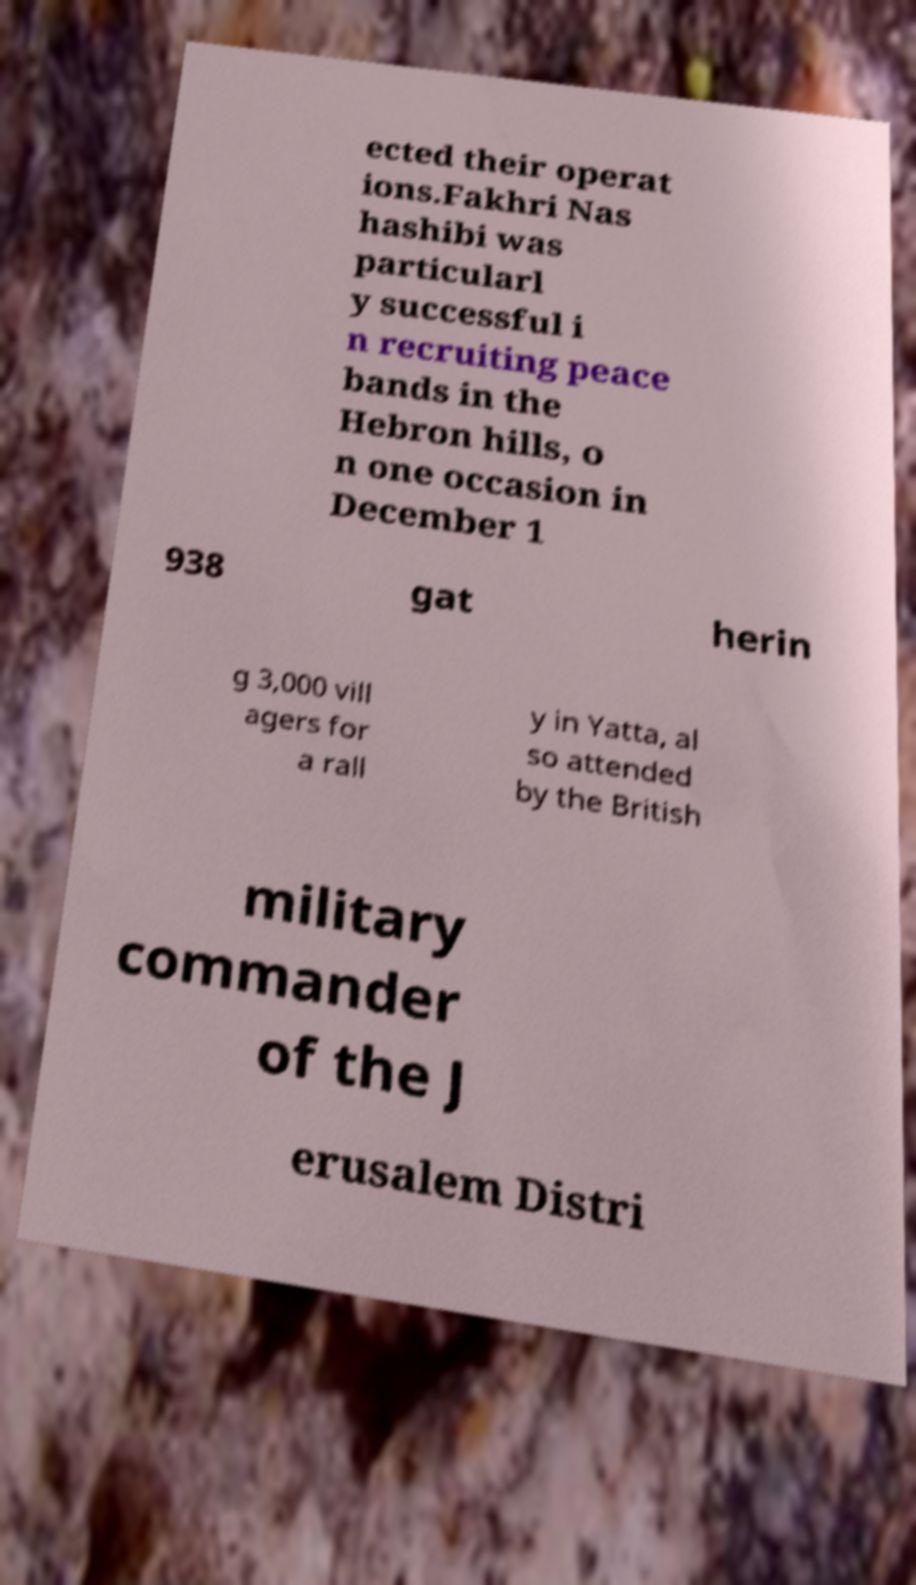Could you extract and type out the text from this image? ected their operat ions.Fakhri Nas hashibi was particularl y successful i n recruiting peace bands in the Hebron hills, o n one occasion in December 1 938 gat herin g 3,000 vill agers for a rall y in Yatta, al so attended by the British military commander of the J erusalem Distri 